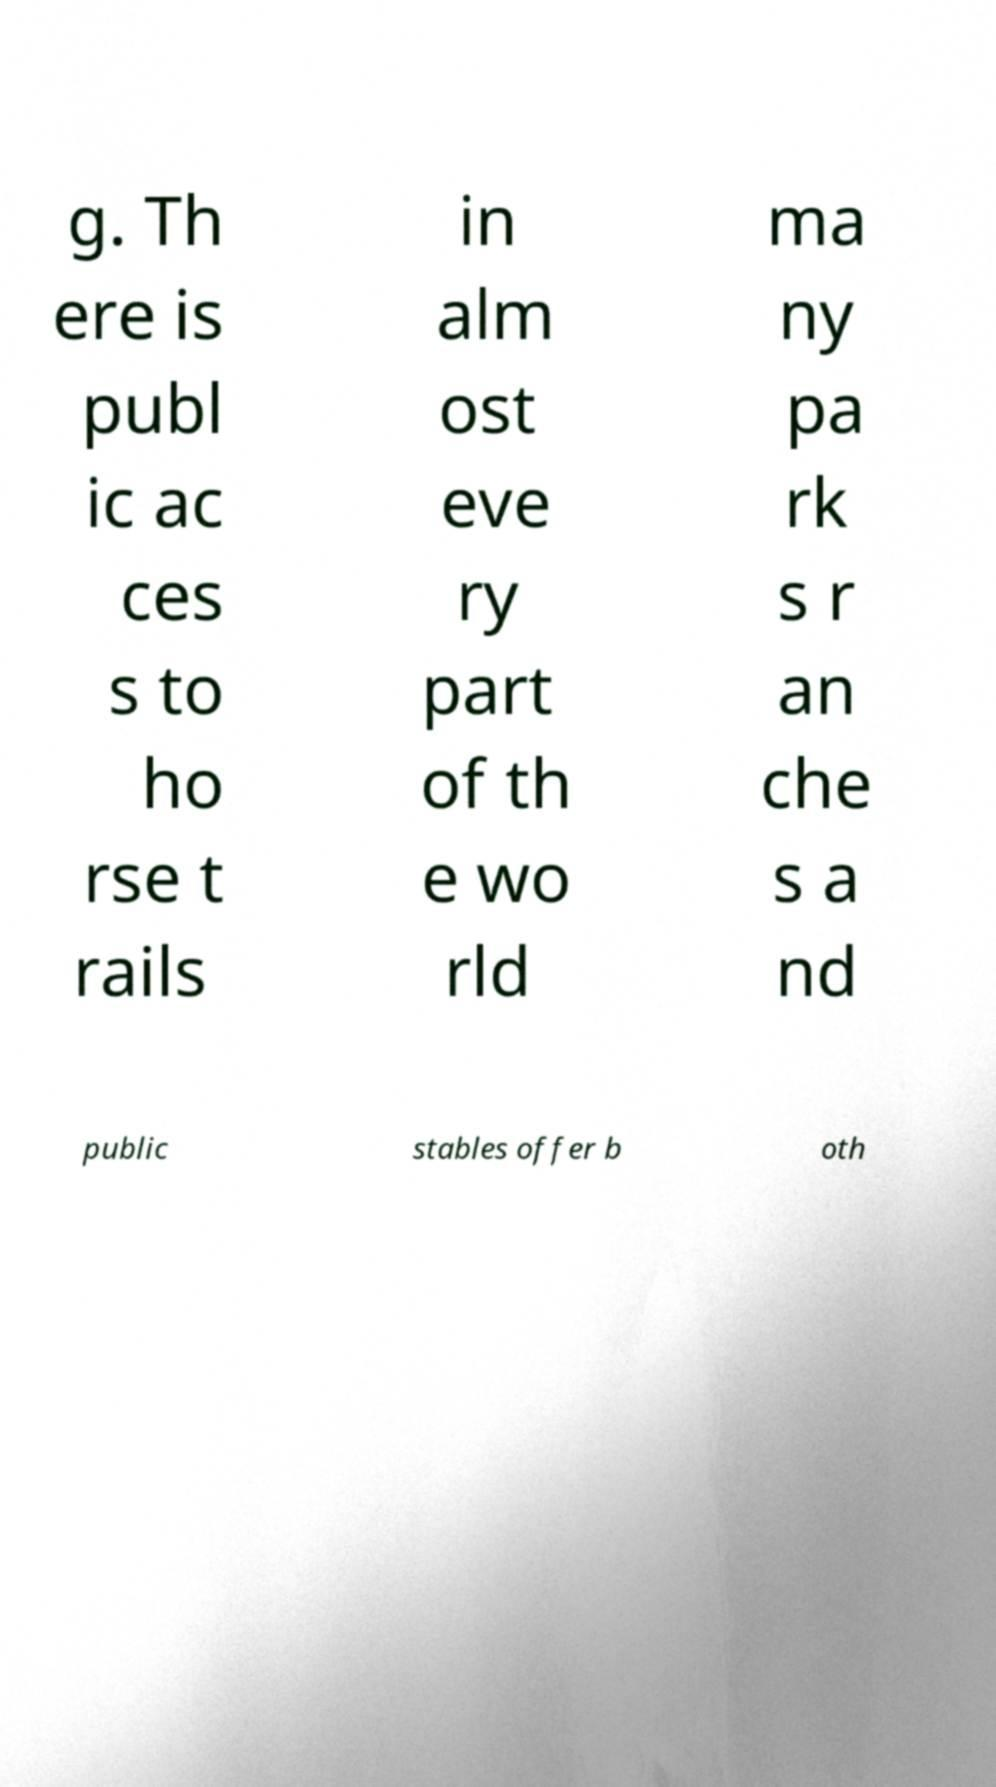Can you read and provide the text displayed in the image?This photo seems to have some interesting text. Can you extract and type it out for me? g. Th ere is publ ic ac ces s to ho rse t rails in alm ost eve ry part of th e wo rld ma ny pa rk s r an che s a nd public stables offer b oth 